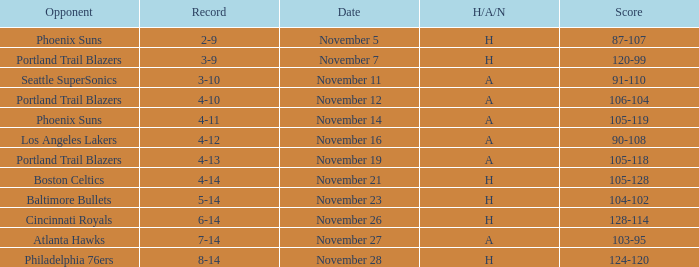What was the Opponent when the Cavaliers had a Record of 3-9? Portland Trail Blazers. 